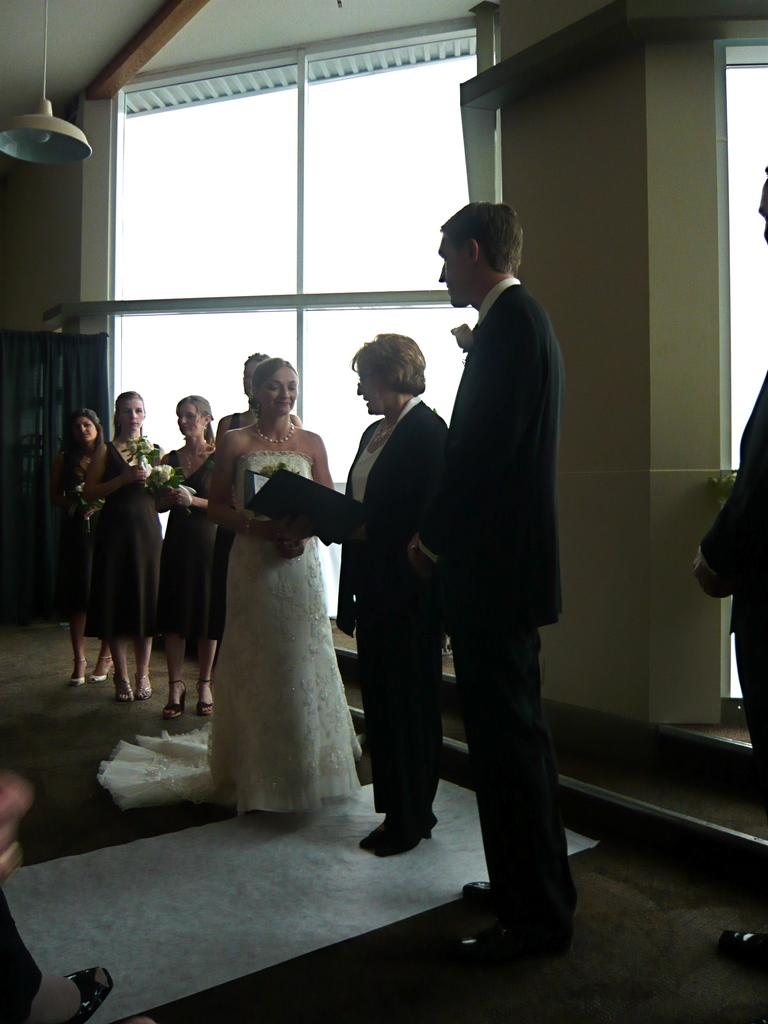What are the people in the image doing? There are people standing in the image, and some of them are holding something. Can you describe what one person is holding? One person is holding a book. What can be seen in the background of the image? There are windows visible in the image, and there is a wall in the image. What is the source of light in the image? There is light in the image, but the specific source is not mentioned. What type of writing can be seen on the hose in the image? There is no hose present in the image, so it is not possible to determine if there is any writing on it. 